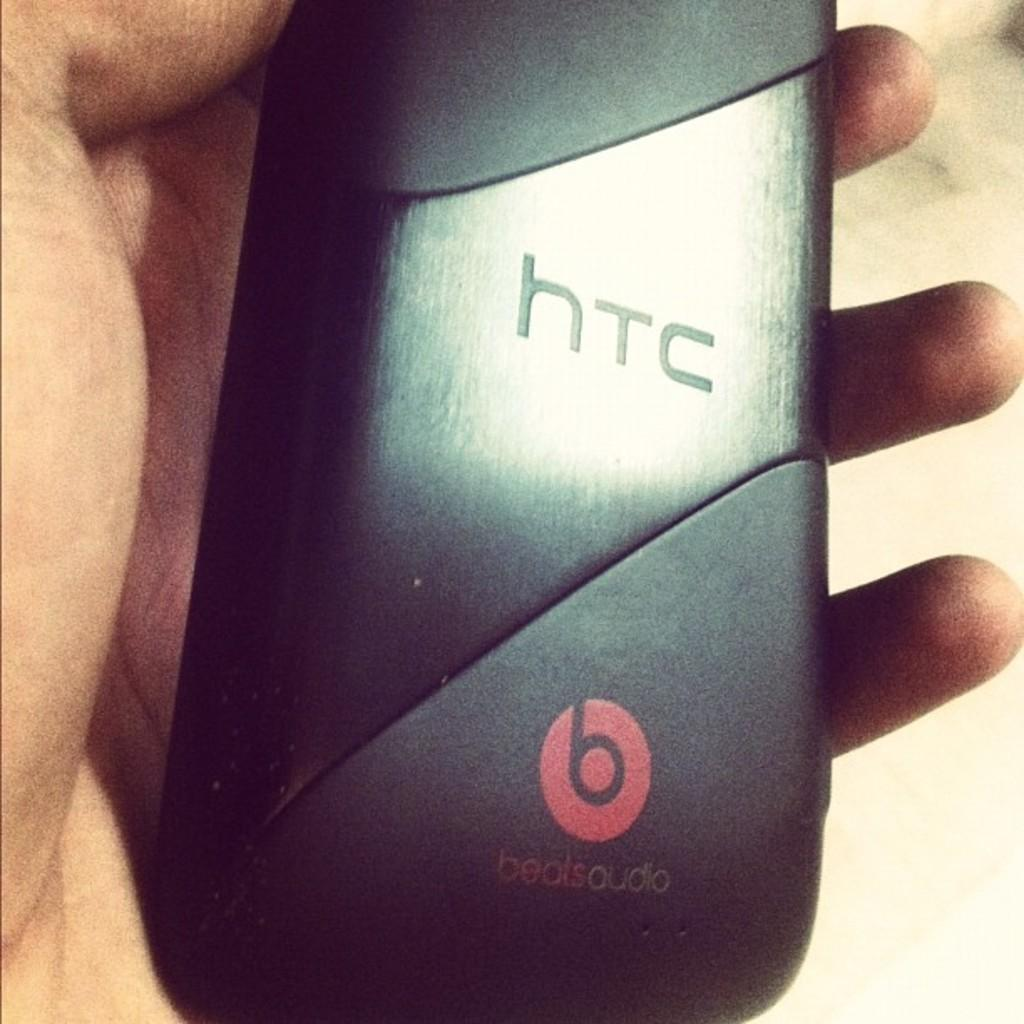<image>
Write a terse but informative summary of the picture. Someone is holding an htc phone with a black case. 